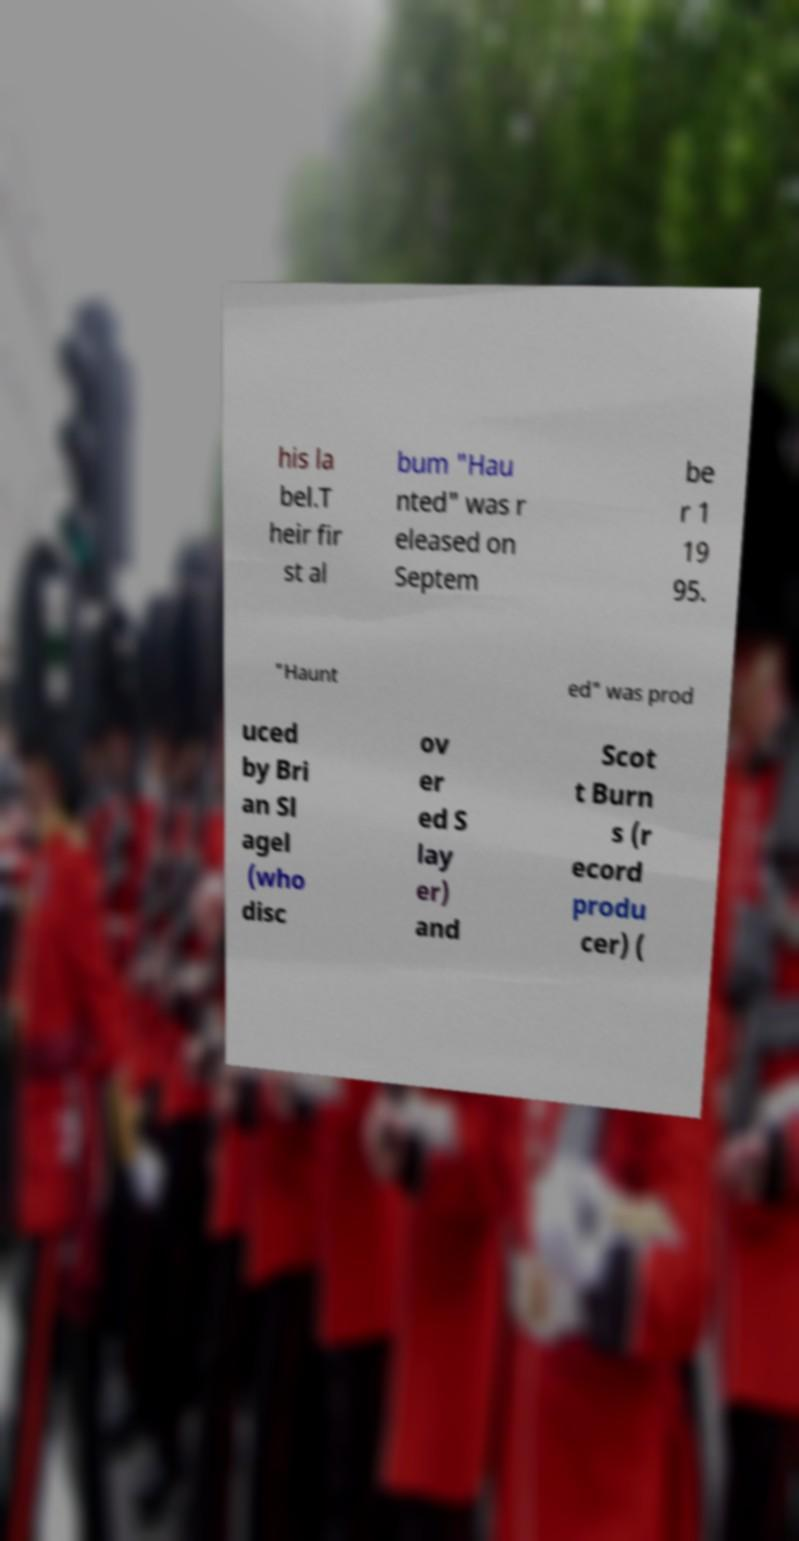Please identify and transcribe the text found in this image. his la bel.T heir fir st al bum "Hau nted" was r eleased on Septem be r 1 19 95. "Haunt ed" was prod uced by Bri an Sl agel (who disc ov er ed S lay er) and Scot t Burn s (r ecord produ cer) ( 